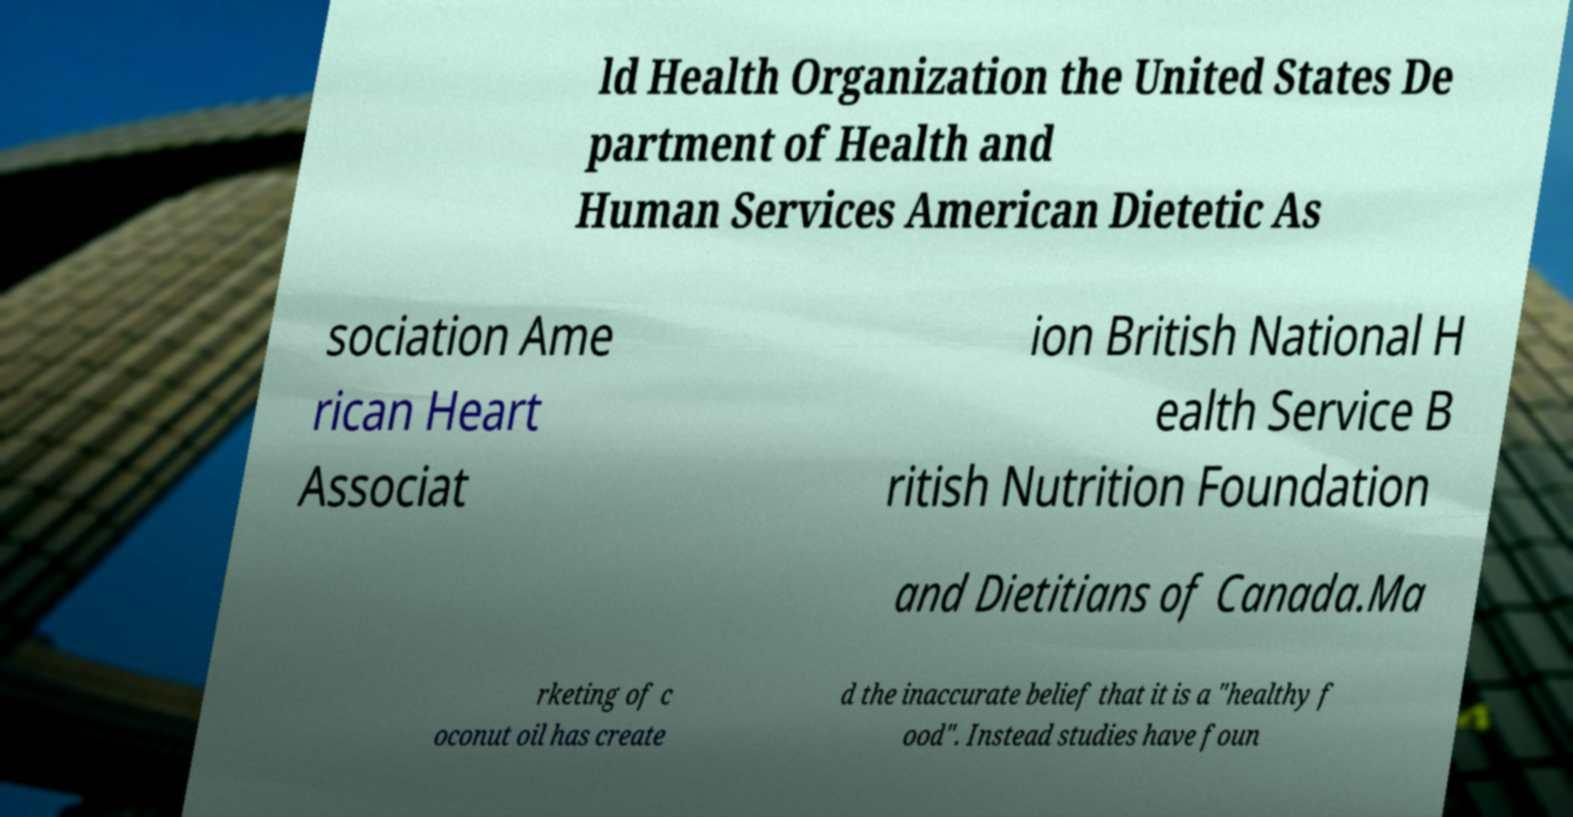Could you assist in decoding the text presented in this image and type it out clearly? ld Health Organization the United States De partment of Health and Human Services American Dietetic As sociation Ame rican Heart Associat ion British National H ealth Service B ritish Nutrition Foundation and Dietitians of Canada.Ma rketing of c oconut oil has create d the inaccurate belief that it is a "healthy f ood". Instead studies have foun 